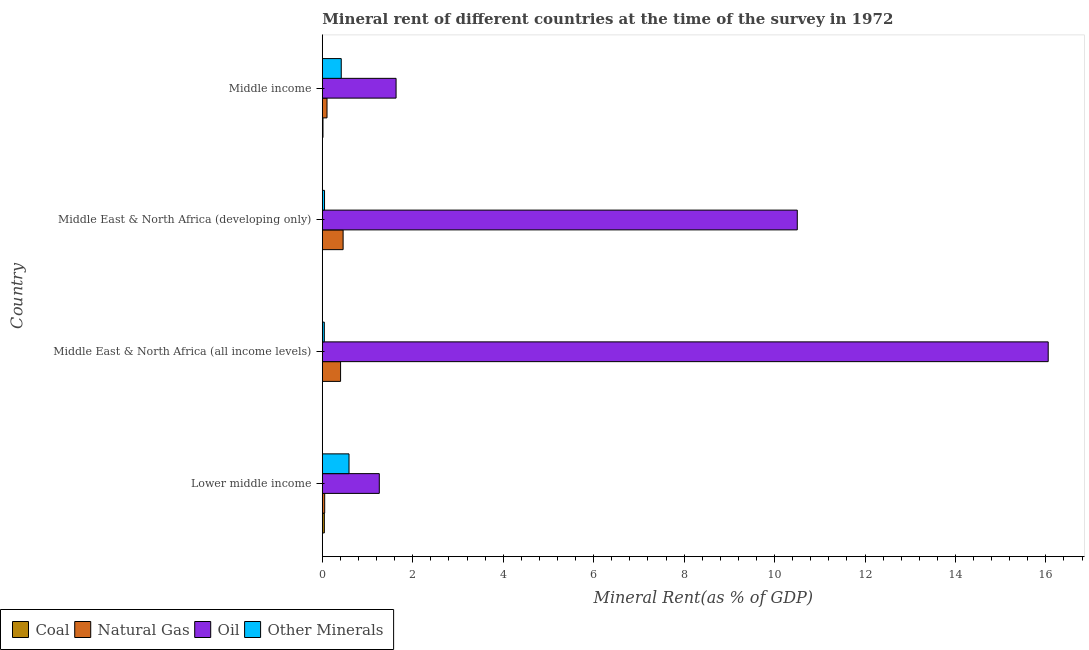How many groups of bars are there?
Keep it short and to the point. 4. Are the number of bars per tick equal to the number of legend labels?
Keep it short and to the point. Yes. Are the number of bars on each tick of the Y-axis equal?
Give a very brief answer. Yes. How many bars are there on the 1st tick from the top?
Give a very brief answer. 4. How many bars are there on the 4th tick from the bottom?
Make the answer very short. 4. What is the label of the 3rd group of bars from the top?
Make the answer very short. Middle East & North Africa (all income levels). What is the natural gas rent in Middle income?
Offer a very short reply. 0.1. Across all countries, what is the maximum  rent of other minerals?
Provide a succinct answer. 0.59. Across all countries, what is the minimum coal rent?
Offer a terse response. 0. In which country was the natural gas rent maximum?
Your response must be concise. Middle East & North Africa (developing only). In which country was the natural gas rent minimum?
Offer a very short reply. Lower middle income. What is the total natural gas rent in the graph?
Offer a terse response. 1.02. What is the difference between the  rent of other minerals in Middle East & North Africa (developing only) and that in Middle income?
Keep it short and to the point. -0.37. What is the difference between the oil rent in Middle income and the  rent of other minerals in Lower middle income?
Provide a short and direct response. 1.04. What is the average  rent of other minerals per country?
Provide a succinct answer. 0.28. What is the difference between the natural gas rent and  rent of other minerals in Middle East & North Africa (developing only)?
Ensure brevity in your answer.  0.41. In how many countries, is the  rent of other minerals greater than 0.4 %?
Your answer should be very brief. 2. What is the ratio of the  rent of other minerals in Lower middle income to that in Middle East & North Africa (developing only)?
Ensure brevity in your answer.  12.13. Is the difference between the natural gas rent in Middle East & North Africa (developing only) and Middle income greater than the difference between the oil rent in Middle East & North Africa (developing only) and Middle income?
Offer a very short reply. No. What is the difference between the highest and the second highest  rent of other minerals?
Your answer should be compact. 0.17. What is the difference between the highest and the lowest natural gas rent?
Your answer should be compact. 0.41. Is the sum of the  rent of other minerals in Middle East & North Africa (developing only) and Middle income greater than the maximum coal rent across all countries?
Provide a succinct answer. Yes. What does the 2nd bar from the top in Middle East & North Africa (developing only) represents?
Give a very brief answer. Oil. What does the 3rd bar from the bottom in Middle East & North Africa (all income levels) represents?
Provide a short and direct response. Oil. How many bars are there?
Provide a short and direct response. 16. How many countries are there in the graph?
Ensure brevity in your answer.  4. What is the difference between two consecutive major ticks on the X-axis?
Provide a succinct answer. 2. Are the values on the major ticks of X-axis written in scientific E-notation?
Your answer should be compact. No. Does the graph contain grids?
Keep it short and to the point. No. What is the title of the graph?
Your answer should be very brief. Mineral rent of different countries at the time of the survey in 1972. What is the label or title of the X-axis?
Provide a short and direct response. Mineral Rent(as % of GDP). What is the Mineral Rent(as % of GDP) of Coal in Lower middle income?
Keep it short and to the point. 0.04. What is the Mineral Rent(as % of GDP) of Natural Gas in Lower middle income?
Your answer should be compact. 0.05. What is the Mineral Rent(as % of GDP) in Oil in Lower middle income?
Provide a short and direct response. 1.26. What is the Mineral Rent(as % of GDP) in Other Minerals in Lower middle income?
Offer a very short reply. 0.59. What is the Mineral Rent(as % of GDP) in Coal in Middle East & North Africa (all income levels)?
Provide a succinct answer. 0. What is the Mineral Rent(as % of GDP) of Natural Gas in Middle East & North Africa (all income levels)?
Ensure brevity in your answer.  0.4. What is the Mineral Rent(as % of GDP) of Oil in Middle East & North Africa (all income levels)?
Ensure brevity in your answer.  16.05. What is the Mineral Rent(as % of GDP) in Other Minerals in Middle East & North Africa (all income levels)?
Offer a terse response. 0.04. What is the Mineral Rent(as % of GDP) of Coal in Middle East & North Africa (developing only)?
Provide a short and direct response. 0. What is the Mineral Rent(as % of GDP) of Natural Gas in Middle East & North Africa (developing only)?
Your answer should be compact. 0.46. What is the Mineral Rent(as % of GDP) of Oil in Middle East & North Africa (developing only)?
Ensure brevity in your answer.  10.5. What is the Mineral Rent(as % of GDP) in Other Minerals in Middle East & North Africa (developing only)?
Your answer should be compact. 0.05. What is the Mineral Rent(as % of GDP) of Coal in Middle income?
Provide a short and direct response. 0.01. What is the Mineral Rent(as % of GDP) of Natural Gas in Middle income?
Offer a terse response. 0.1. What is the Mineral Rent(as % of GDP) in Oil in Middle income?
Provide a succinct answer. 1.63. What is the Mineral Rent(as % of GDP) of Other Minerals in Middle income?
Ensure brevity in your answer.  0.42. Across all countries, what is the maximum Mineral Rent(as % of GDP) in Coal?
Your answer should be compact. 0.04. Across all countries, what is the maximum Mineral Rent(as % of GDP) in Natural Gas?
Provide a succinct answer. 0.46. Across all countries, what is the maximum Mineral Rent(as % of GDP) in Oil?
Make the answer very short. 16.05. Across all countries, what is the maximum Mineral Rent(as % of GDP) of Other Minerals?
Your answer should be compact. 0.59. Across all countries, what is the minimum Mineral Rent(as % of GDP) of Coal?
Your answer should be very brief. 0. Across all countries, what is the minimum Mineral Rent(as % of GDP) in Natural Gas?
Make the answer very short. 0.05. Across all countries, what is the minimum Mineral Rent(as % of GDP) in Oil?
Provide a short and direct response. 1.26. Across all countries, what is the minimum Mineral Rent(as % of GDP) in Other Minerals?
Keep it short and to the point. 0.04. What is the total Mineral Rent(as % of GDP) of Coal in the graph?
Give a very brief answer. 0.06. What is the total Mineral Rent(as % of GDP) of Natural Gas in the graph?
Offer a very short reply. 1.02. What is the total Mineral Rent(as % of GDP) of Oil in the graph?
Offer a terse response. 29.44. What is the total Mineral Rent(as % of GDP) in Other Minerals in the graph?
Your response must be concise. 1.1. What is the difference between the Mineral Rent(as % of GDP) of Coal in Lower middle income and that in Middle East & North Africa (all income levels)?
Ensure brevity in your answer.  0.04. What is the difference between the Mineral Rent(as % of GDP) of Natural Gas in Lower middle income and that in Middle East & North Africa (all income levels)?
Give a very brief answer. -0.35. What is the difference between the Mineral Rent(as % of GDP) in Oil in Lower middle income and that in Middle East & North Africa (all income levels)?
Ensure brevity in your answer.  -14.79. What is the difference between the Mineral Rent(as % of GDP) in Other Minerals in Lower middle income and that in Middle East & North Africa (all income levels)?
Make the answer very short. 0.55. What is the difference between the Mineral Rent(as % of GDP) in Coal in Lower middle income and that in Middle East & North Africa (developing only)?
Your answer should be compact. 0.04. What is the difference between the Mineral Rent(as % of GDP) in Natural Gas in Lower middle income and that in Middle East & North Africa (developing only)?
Make the answer very short. -0.41. What is the difference between the Mineral Rent(as % of GDP) in Oil in Lower middle income and that in Middle East & North Africa (developing only)?
Give a very brief answer. -9.24. What is the difference between the Mineral Rent(as % of GDP) of Other Minerals in Lower middle income and that in Middle East & North Africa (developing only)?
Keep it short and to the point. 0.54. What is the difference between the Mineral Rent(as % of GDP) in Natural Gas in Lower middle income and that in Middle income?
Keep it short and to the point. -0.05. What is the difference between the Mineral Rent(as % of GDP) in Oil in Lower middle income and that in Middle income?
Your response must be concise. -0.37. What is the difference between the Mineral Rent(as % of GDP) of Other Minerals in Lower middle income and that in Middle income?
Keep it short and to the point. 0.17. What is the difference between the Mineral Rent(as % of GDP) in Coal in Middle East & North Africa (all income levels) and that in Middle East & North Africa (developing only)?
Your answer should be compact. -0. What is the difference between the Mineral Rent(as % of GDP) of Natural Gas in Middle East & North Africa (all income levels) and that in Middle East & North Africa (developing only)?
Provide a short and direct response. -0.06. What is the difference between the Mineral Rent(as % of GDP) of Oil in Middle East & North Africa (all income levels) and that in Middle East & North Africa (developing only)?
Your answer should be compact. 5.55. What is the difference between the Mineral Rent(as % of GDP) of Other Minerals in Middle East & North Africa (all income levels) and that in Middle East & North Africa (developing only)?
Your answer should be very brief. -0. What is the difference between the Mineral Rent(as % of GDP) in Coal in Middle East & North Africa (all income levels) and that in Middle income?
Keep it short and to the point. -0.01. What is the difference between the Mineral Rent(as % of GDP) of Natural Gas in Middle East & North Africa (all income levels) and that in Middle income?
Ensure brevity in your answer.  0.3. What is the difference between the Mineral Rent(as % of GDP) of Oil in Middle East & North Africa (all income levels) and that in Middle income?
Offer a terse response. 14.42. What is the difference between the Mineral Rent(as % of GDP) of Other Minerals in Middle East & North Africa (all income levels) and that in Middle income?
Provide a succinct answer. -0.37. What is the difference between the Mineral Rent(as % of GDP) of Coal in Middle East & North Africa (developing only) and that in Middle income?
Give a very brief answer. -0.01. What is the difference between the Mineral Rent(as % of GDP) of Natural Gas in Middle East & North Africa (developing only) and that in Middle income?
Offer a terse response. 0.36. What is the difference between the Mineral Rent(as % of GDP) of Oil in Middle East & North Africa (developing only) and that in Middle income?
Give a very brief answer. 8.87. What is the difference between the Mineral Rent(as % of GDP) of Other Minerals in Middle East & North Africa (developing only) and that in Middle income?
Provide a succinct answer. -0.37. What is the difference between the Mineral Rent(as % of GDP) of Coal in Lower middle income and the Mineral Rent(as % of GDP) of Natural Gas in Middle East & North Africa (all income levels)?
Your answer should be very brief. -0.36. What is the difference between the Mineral Rent(as % of GDP) of Coal in Lower middle income and the Mineral Rent(as % of GDP) of Oil in Middle East & North Africa (all income levels)?
Ensure brevity in your answer.  -16.01. What is the difference between the Mineral Rent(as % of GDP) of Coal in Lower middle income and the Mineral Rent(as % of GDP) of Other Minerals in Middle East & North Africa (all income levels)?
Offer a terse response. 0. What is the difference between the Mineral Rent(as % of GDP) of Natural Gas in Lower middle income and the Mineral Rent(as % of GDP) of Oil in Middle East & North Africa (all income levels)?
Your response must be concise. -16. What is the difference between the Mineral Rent(as % of GDP) in Natural Gas in Lower middle income and the Mineral Rent(as % of GDP) in Other Minerals in Middle East & North Africa (all income levels)?
Provide a short and direct response. 0.01. What is the difference between the Mineral Rent(as % of GDP) of Oil in Lower middle income and the Mineral Rent(as % of GDP) of Other Minerals in Middle East & North Africa (all income levels)?
Make the answer very short. 1.22. What is the difference between the Mineral Rent(as % of GDP) of Coal in Lower middle income and the Mineral Rent(as % of GDP) of Natural Gas in Middle East & North Africa (developing only)?
Offer a terse response. -0.41. What is the difference between the Mineral Rent(as % of GDP) in Coal in Lower middle income and the Mineral Rent(as % of GDP) in Oil in Middle East & North Africa (developing only)?
Give a very brief answer. -10.46. What is the difference between the Mineral Rent(as % of GDP) in Coal in Lower middle income and the Mineral Rent(as % of GDP) in Other Minerals in Middle East & North Africa (developing only)?
Your answer should be compact. -0. What is the difference between the Mineral Rent(as % of GDP) in Natural Gas in Lower middle income and the Mineral Rent(as % of GDP) in Oil in Middle East & North Africa (developing only)?
Give a very brief answer. -10.45. What is the difference between the Mineral Rent(as % of GDP) in Natural Gas in Lower middle income and the Mineral Rent(as % of GDP) in Other Minerals in Middle East & North Africa (developing only)?
Your answer should be compact. 0. What is the difference between the Mineral Rent(as % of GDP) in Oil in Lower middle income and the Mineral Rent(as % of GDP) in Other Minerals in Middle East & North Africa (developing only)?
Provide a succinct answer. 1.21. What is the difference between the Mineral Rent(as % of GDP) of Coal in Lower middle income and the Mineral Rent(as % of GDP) of Natural Gas in Middle income?
Your answer should be very brief. -0.06. What is the difference between the Mineral Rent(as % of GDP) in Coal in Lower middle income and the Mineral Rent(as % of GDP) in Oil in Middle income?
Your answer should be compact. -1.59. What is the difference between the Mineral Rent(as % of GDP) of Coal in Lower middle income and the Mineral Rent(as % of GDP) of Other Minerals in Middle income?
Give a very brief answer. -0.37. What is the difference between the Mineral Rent(as % of GDP) in Natural Gas in Lower middle income and the Mineral Rent(as % of GDP) in Oil in Middle income?
Offer a terse response. -1.58. What is the difference between the Mineral Rent(as % of GDP) in Natural Gas in Lower middle income and the Mineral Rent(as % of GDP) in Other Minerals in Middle income?
Provide a succinct answer. -0.37. What is the difference between the Mineral Rent(as % of GDP) of Oil in Lower middle income and the Mineral Rent(as % of GDP) of Other Minerals in Middle income?
Offer a very short reply. 0.84. What is the difference between the Mineral Rent(as % of GDP) in Coal in Middle East & North Africa (all income levels) and the Mineral Rent(as % of GDP) in Natural Gas in Middle East & North Africa (developing only)?
Keep it short and to the point. -0.46. What is the difference between the Mineral Rent(as % of GDP) of Coal in Middle East & North Africa (all income levels) and the Mineral Rent(as % of GDP) of Oil in Middle East & North Africa (developing only)?
Make the answer very short. -10.5. What is the difference between the Mineral Rent(as % of GDP) in Coal in Middle East & North Africa (all income levels) and the Mineral Rent(as % of GDP) in Other Minerals in Middle East & North Africa (developing only)?
Your answer should be very brief. -0.05. What is the difference between the Mineral Rent(as % of GDP) in Natural Gas in Middle East & North Africa (all income levels) and the Mineral Rent(as % of GDP) in Oil in Middle East & North Africa (developing only)?
Offer a terse response. -10.1. What is the difference between the Mineral Rent(as % of GDP) of Natural Gas in Middle East & North Africa (all income levels) and the Mineral Rent(as % of GDP) of Other Minerals in Middle East & North Africa (developing only)?
Give a very brief answer. 0.35. What is the difference between the Mineral Rent(as % of GDP) of Oil in Middle East & North Africa (all income levels) and the Mineral Rent(as % of GDP) of Other Minerals in Middle East & North Africa (developing only)?
Keep it short and to the point. 16. What is the difference between the Mineral Rent(as % of GDP) of Coal in Middle East & North Africa (all income levels) and the Mineral Rent(as % of GDP) of Natural Gas in Middle income?
Provide a short and direct response. -0.1. What is the difference between the Mineral Rent(as % of GDP) in Coal in Middle East & North Africa (all income levels) and the Mineral Rent(as % of GDP) in Oil in Middle income?
Keep it short and to the point. -1.63. What is the difference between the Mineral Rent(as % of GDP) of Coal in Middle East & North Africa (all income levels) and the Mineral Rent(as % of GDP) of Other Minerals in Middle income?
Provide a short and direct response. -0.42. What is the difference between the Mineral Rent(as % of GDP) of Natural Gas in Middle East & North Africa (all income levels) and the Mineral Rent(as % of GDP) of Oil in Middle income?
Offer a terse response. -1.23. What is the difference between the Mineral Rent(as % of GDP) of Natural Gas in Middle East & North Africa (all income levels) and the Mineral Rent(as % of GDP) of Other Minerals in Middle income?
Make the answer very short. -0.01. What is the difference between the Mineral Rent(as % of GDP) in Oil in Middle East & North Africa (all income levels) and the Mineral Rent(as % of GDP) in Other Minerals in Middle income?
Provide a succinct answer. 15.63. What is the difference between the Mineral Rent(as % of GDP) of Coal in Middle East & North Africa (developing only) and the Mineral Rent(as % of GDP) of Natural Gas in Middle income?
Offer a very short reply. -0.1. What is the difference between the Mineral Rent(as % of GDP) of Coal in Middle East & North Africa (developing only) and the Mineral Rent(as % of GDP) of Oil in Middle income?
Offer a very short reply. -1.63. What is the difference between the Mineral Rent(as % of GDP) in Coal in Middle East & North Africa (developing only) and the Mineral Rent(as % of GDP) in Other Minerals in Middle income?
Provide a succinct answer. -0.42. What is the difference between the Mineral Rent(as % of GDP) of Natural Gas in Middle East & North Africa (developing only) and the Mineral Rent(as % of GDP) of Oil in Middle income?
Your response must be concise. -1.17. What is the difference between the Mineral Rent(as % of GDP) of Natural Gas in Middle East & North Africa (developing only) and the Mineral Rent(as % of GDP) of Other Minerals in Middle income?
Offer a terse response. 0.04. What is the difference between the Mineral Rent(as % of GDP) of Oil in Middle East & North Africa (developing only) and the Mineral Rent(as % of GDP) of Other Minerals in Middle income?
Offer a very short reply. 10.08. What is the average Mineral Rent(as % of GDP) in Coal per country?
Your answer should be compact. 0.02. What is the average Mineral Rent(as % of GDP) of Natural Gas per country?
Ensure brevity in your answer.  0.25. What is the average Mineral Rent(as % of GDP) in Oil per country?
Offer a very short reply. 7.36. What is the average Mineral Rent(as % of GDP) in Other Minerals per country?
Make the answer very short. 0.28. What is the difference between the Mineral Rent(as % of GDP) in Coal and Mineral Rent(as % of GDP) in Natural Gas in Lower middle income?
Provide a succinct answer. -0.01. What is the difference between the Mineral Rent(as % of GDP) in Coal and Mineral Rent(as % of GDP) in Oil in Lower middle income?
Ensure brevity in your answer.  -1.22. What is the difference between the Mineral Rent(as % of GDP) of Coal and Mineral Rent(as % of GDP) of Other Minerals in Lower middle income?
Keep it short and to the point. -0.55. What is the difference between the Mineral Rent(as % of GDP) in Natural Gas and Mineral Rent(as % of GDP) in Oil in Lower middle income?
Your answer should be very brief. -1.21. What is the difference between the Mineral Rent(as % of GDP) of Natural Gas and Mineral Rent(as % of GDP) of Other Minerals in Lower middle income?
Offer a terse response. -0.54. What is the difference between the Mineral Rent(as % of GDP) in Oil and Mineral Rent(as % of GDP) in Other Minerals in Lower middle income?
Your response must be concise. 0.67. What is the difference between the Mineral Rent(as % of GDP) in Coal and Mineral Rent(as % of GDP) in Natural Gas in Middle East & North Africa (all income levels)?
Make the answer very short. -0.4. What is the difference between the Mineral Rent(as % of GDP) in Coal and Mineral Rent(as % of GDP) in Oil in Middle East & North Africa (all income levels)?
Give a very brief answer. -16.05. What is the difference between the Mineral Rent(as % of GDP) in Coal and Mineral Rent(as % of GDP) in Other Minerals in Middle East & North Africa (all income levels)?
Give a very brief answer. -0.04. What is the difference between the Mineral Rent(as % of GDP) in Natural Gas and Mineral Rent(as % of GDP) in Oil in Middle East & North Africa (all income levels)?
Your response must be concise. -15.65. What is the difference between the Mineral Rent(as % of GDP) in Natural Gas and Mineral Rent(as % of GDP) in Other Minerals in Middle East & North Africa (all income levels)?
Ensure brevity in your answer.  0.36. What is the difference between the Mineral Rent(as % of GDP) of Oil and Mineral Rent(as % of GDP) of Other Minerals in Middle East & North Africa (all income levels)?
Your answer should be compact. 16.01. What is the difference between the Mineral Rent(as % of GDP) in Coal and Mineral Rent(as % of GDP) in Natural Gas in Middle East & North Africa (developing only)?
Offer a very short reply. -0.46. What is the difference between the Mineral Rent(as % of GDP) of Coal and Mineral Rent(as % of GDP) of Oil in Middle East & North Africa (developing only)?
Ensure brevity in your answer.  -10.5. What is the difference between the Mineral Rent(as % of GDP) in Coal and Mineral Rent(as % of GDP) in Other Minerals in Middle East & North Africa (developing only)?
Your answer should be compact. -0.05. What is the difference between the Mineral Rent(as % of GDP) in Natural Gas and Mineral Rent(as % of GDP) in Oil in Middle East & North Africa (developing only)?
Offer a very short reply. -10.04. What is the difference between the Mineral Rent(as % of GDP) in Natural Gas and Mineral Rent(as % of GDP) in Other Minerals in Middle East & North Africa (developing only)?
Keep it short and to the point. 0.41. What is the difference between the Mineral Rent(as % of GDP) in Oil and Mineral Rent(as % of GDP) in Other Minerals in Middle East & North Africa (developing only)?
Keep it short and to the point. 10.45. What is the difference between the Mineral Rent(as % of GDP) in Coal and Mineral Rent(as % of GDP) in Natural Gas in Middle income?
Provide a short and direct response. -0.09. What is the difference between the Mineral Rent(as % of GDP) of Coal and Mineral Rent(as % of GDP) of Oil in Middle income?
Provide a succinct answer. -1.62. What is the difference between the Mineral Rent(as % of GDP) in Coal and Mineral Rent(as % of GDP) in Other Minerals in Middle income?
Make the answer very short. -0.4. What is the difference between the Mineral Rent(as % of GDP) in Natural Gas and Mineral Rent(as % of GDP) in Oil in Middle income?
Give a very brief answer. -1.53. What is the difference between the Mineral Rent(as % of GDP) in Natural Gas and Mineral Rent(as % of GDP) in Other Minerals in Middle income?
Keep it short and to the point. -0.31. What is the difference between the Mineral Rent(as % of GDP) of Oil and Mineral Rent(as % of GDP) of Other Minerals in Middle income?
Provide a short and direct response. 1.21. What is the ratio of the Mineral Rent(as % of GDP) of Coal in Lower middle income to that in Middle East & North Africa (all income levels)?
Your answer should be very brief. 43.7. What is the ratio of the Mineral Rent(as % of GDP) in Natural Gas in Lower middle income to that in Middle East & North Africa (all income levels)?
Your response must be concise. 0.13. What is the ratio of the Mineral Rent(as % of GDP) in Oil in Lower middle income to that in Middle East & North Africa (all income levels)?
Offer a terse response. 0.08. What is the ratio of the Mineral Rent(as % of GDP) in Other Minerals in Lower middle income to that in Middle East & North Africa (all income levels)?
Provide a succinct answer. 13.42. What is the ratio of the Mineral Rent(as % of GDP) of Coal in Lower middle income to that in Middle East & North Africa (developing only)?
Ensure brevity in your answer.  29.76. What is the ratio of the Mineral Rent(as % of GDP) of Natural Gas in Lower middle income to that in Middle East & North Africa (developing only)?
Your answer should be compact. 0.11. What is the ratio of the Mineral Rent(as % of GDP) of Oil in Lower middle income to that in Middle East & North Africa (developing only)?
Offer a terse response. 0.12. What is the ratio of the Mineral Rent(as % of GDP) of Other Minerals in Lower middle income to that in Middle East & North Africa (developing only)?
Keep it short and to the point. 12.13. What is the ratio of the Mineral Rent(as % of GDP) in Coal in Lower middle income to that in Middle income?
Make the answer very short. 3.06. What is the ratio of the Mineral Rent(as % of GDP) of Natural Gas in Lower middle income to that in Middle income?
Make the answer very short. 0.5. What is the ratio of the Mineral Rent(as % of GDP) in Oil in Lower middle income to that in Middle income?
Your answer should be compact. 0.77. What is the ratio of the Mineral Rent(as % of GDP) in Other Minerals in Lower middle income to that in Middle income?
Keep it short and to the point. 1.41. What is the ratio of the Mineral Rent(as % of GDP) in Coal in Middle East & North Africa (all income levels) to that in Middle East & North Africa (developing only)?
Your answer should be compact. 0.68. What is the ratio of the Mineral Rent(as % of GDP) in Natural Gas in Middle East & North Africa (all income levels) to that in Middle East & North Africa (developing only)?
Offer a terse response. 0.88. What is the ratio of the Mineral Rent(as % of GDP) in Oil in Middle East & North Africa (all income levels) to that in Middle East & North Africa (developing only)?
Provide a short and direct response. 1.53. What is the ratio of the Mineral Rent(as % of GDP) in Other Minerals in Middle East & North Africa (all income levels) to that in Middle East & North Africa (developing only)?
Give a very brief answer. 0.9. What is the ratio of the Mineral Rent(as % of GDP) in Coal in Middle East & North Africa (all income levels) to that in Middle income?
Ensure brevity in your answer.  0.07. What is the ratio of the Mineral Rent(as % of GDP) of Natural Gas in Middle East & North Africa (all income levels) to that in Middle income?
Offer a terse response. 3.89. What is the ratio of the Mineral Rent(as % of GDP) of Oil in Middle East & North Africa (all income levels) to that in Middle income?
Keep it short and to the point. 9.84. What is the ratio of the Mineral Rent(as % of GDP) of Other Minerals in Middle East & North Africa (all income levels) to that in Middle income?
Your answer should be very brief. 0.11. What is the ratio of the Mineral Rent(as % of GDP) of Coal in Middle East & North Africa (developing only) to that in Middle income?
Offer a very short reply. 0.1. What is the ratio of the Mineral Rent(as % of GDP) of Natural Gas in Middle East & North Africa (developing only) to that in Middle income?
Provide a short and direct response. 4.44. What is the ratio of the Mineral Rent(as % of GDP) in Oil in Middle East & North Africa (developing only) to that in Middle income?
Offer a terse response. 6.44. What is the ratio of the Mineral Rent(as % of GDP) of Other Minerals in Middle East & North Africa (developing only) to that in Middle income?
Offer a very short reply. 0.12. What is the difference between the highest and the second highest Mineral Rent(as % of GDP) of Natural Gas?
Your answer should be very brief. 0.06. What is the difference between the highest and the second highest Mineral Rent(as % of GDP) in Oil?
Offer a very short reply. 5.55. What is the difference between the highest and the second highest Mineral Rent(as % of GDP) in Other Minerals?
Make the answer very short. 0.17. What is the difference between the highest and the lowest Mineral Rent(as % of GDP) in Coal?
Provide a succinct answer. 0.04. What is the difference between the highest and the lowest Mineral Rent(as % of GDP) in Natural Gas?
Your answer should be compact. 0.41. What is the difference between the highest and the lowest Mineral Rent(as % of GDP) in Oil?
Give a very brief answer. 14.79. What is the difference between the highest and the lowest Mineral Rent(as % of GDP) of Other Minerals?
Offer a very short reply. 0.55. 